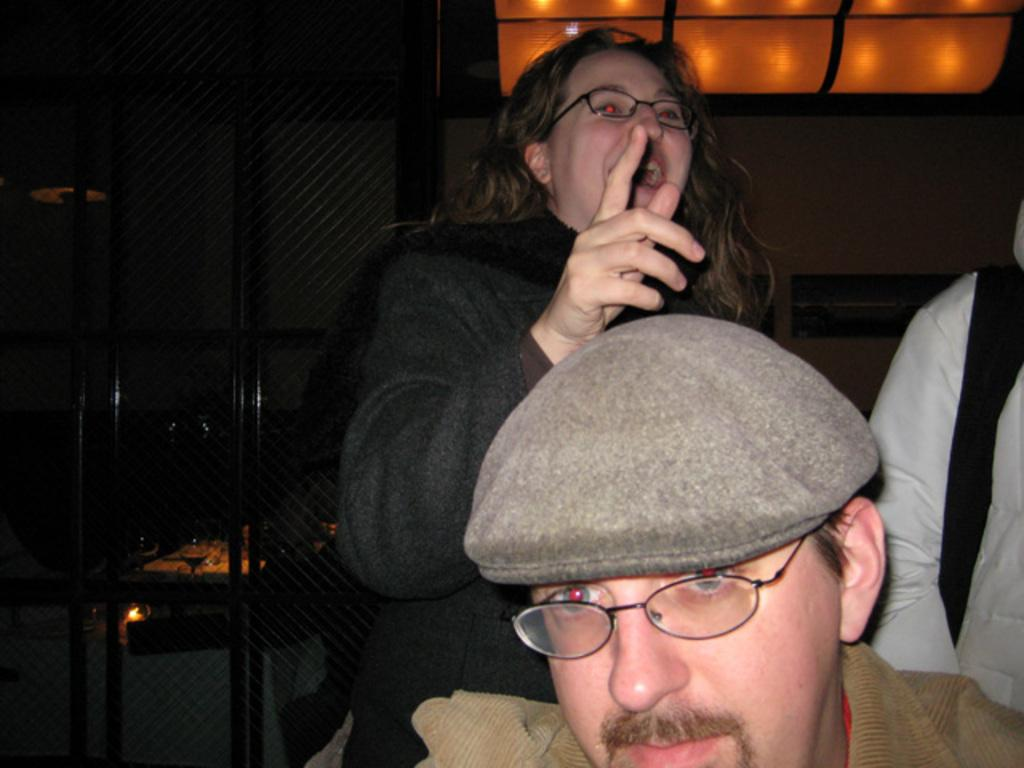What is the main subject in the foreground of the picture? There is a man in the foreground of the picture. Can you describe the man's appearance? The man is wearing a hat and spectacles. What can be seen in the background of the picture? In the background, there is a mesh, metal rods, two persons, lights, and some other objects. What type of vest is the man wearing in the picture? The provided facts do not mention a vest; the man is wearing a hat and spectacles. Can you see a brush being used by the man in the picture? There is no brush visible in the picture; the man is wearing a hat and spectacles. 